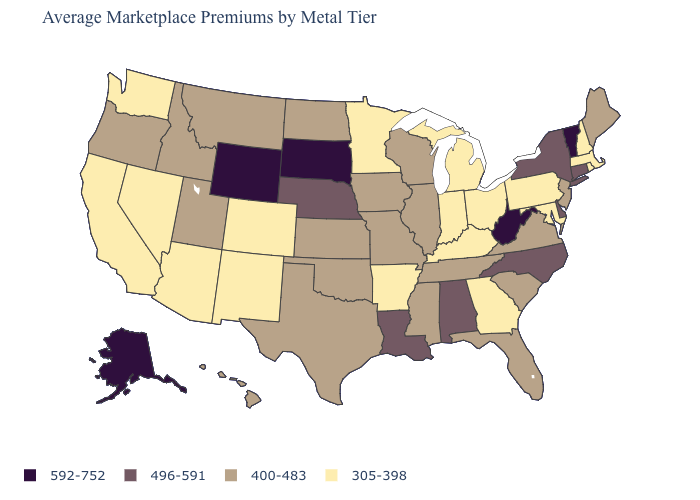What is the lowest value in the Northeast?
Keep it brief. 305-398. Name the states that have a value in the range 400-483?
Be succinct. Florida, Hawaii, Idaho, Illinois, Iowa, Kansas, Maine, Mississippi, Missouri, Montana, New Jersey, North Dakota, Oklahoma, Oregon, South Carolina, Tennessee, Texas, Utah, Virginia, Wisconsin. Which states hav the highest value in the MidWest?
Answer briefly. South Dakota. Name the states that have a value in the range 400-483?
Concise answer only. Florida, Hawaii, Idaho, Illinois, Iowa, Kansas, Maine, Mississippi, Missouri, Montana, New Jersey, North Dakota, Oklahoma, Oregon, South Carolina, Tennessee, Texas, Utah, Virginia, Wisconsin. What is the value of South Carolina?
Short answer required. 400-483. What is the value of Tennessee?
Keep it brief. 400-483. What is the value of Tennessee?
Give a very brief answer. 400-483. What is the value of Iowa?
Keep it brief. 400-483. What is the lowest value in states that border Connecticut?
Keep it brief. 305-398. What is the value of Texas?
Quick response, please. 400-483. Does Maine have a lower value than Nebraska?
Be succinct. Yes. Name the states that have a value in the range 592-752?
Write a very short answer. Alaska, South Dakota, Vermont, West Virginia, Wyoming. Does South Dakota have the lowest value in the USA?
Keep it brief. No. Which states hav the highest value in the MidWest?
Concise answer only. South Dakota. Is the legend a continuous bar?
Answer briefly. No. 